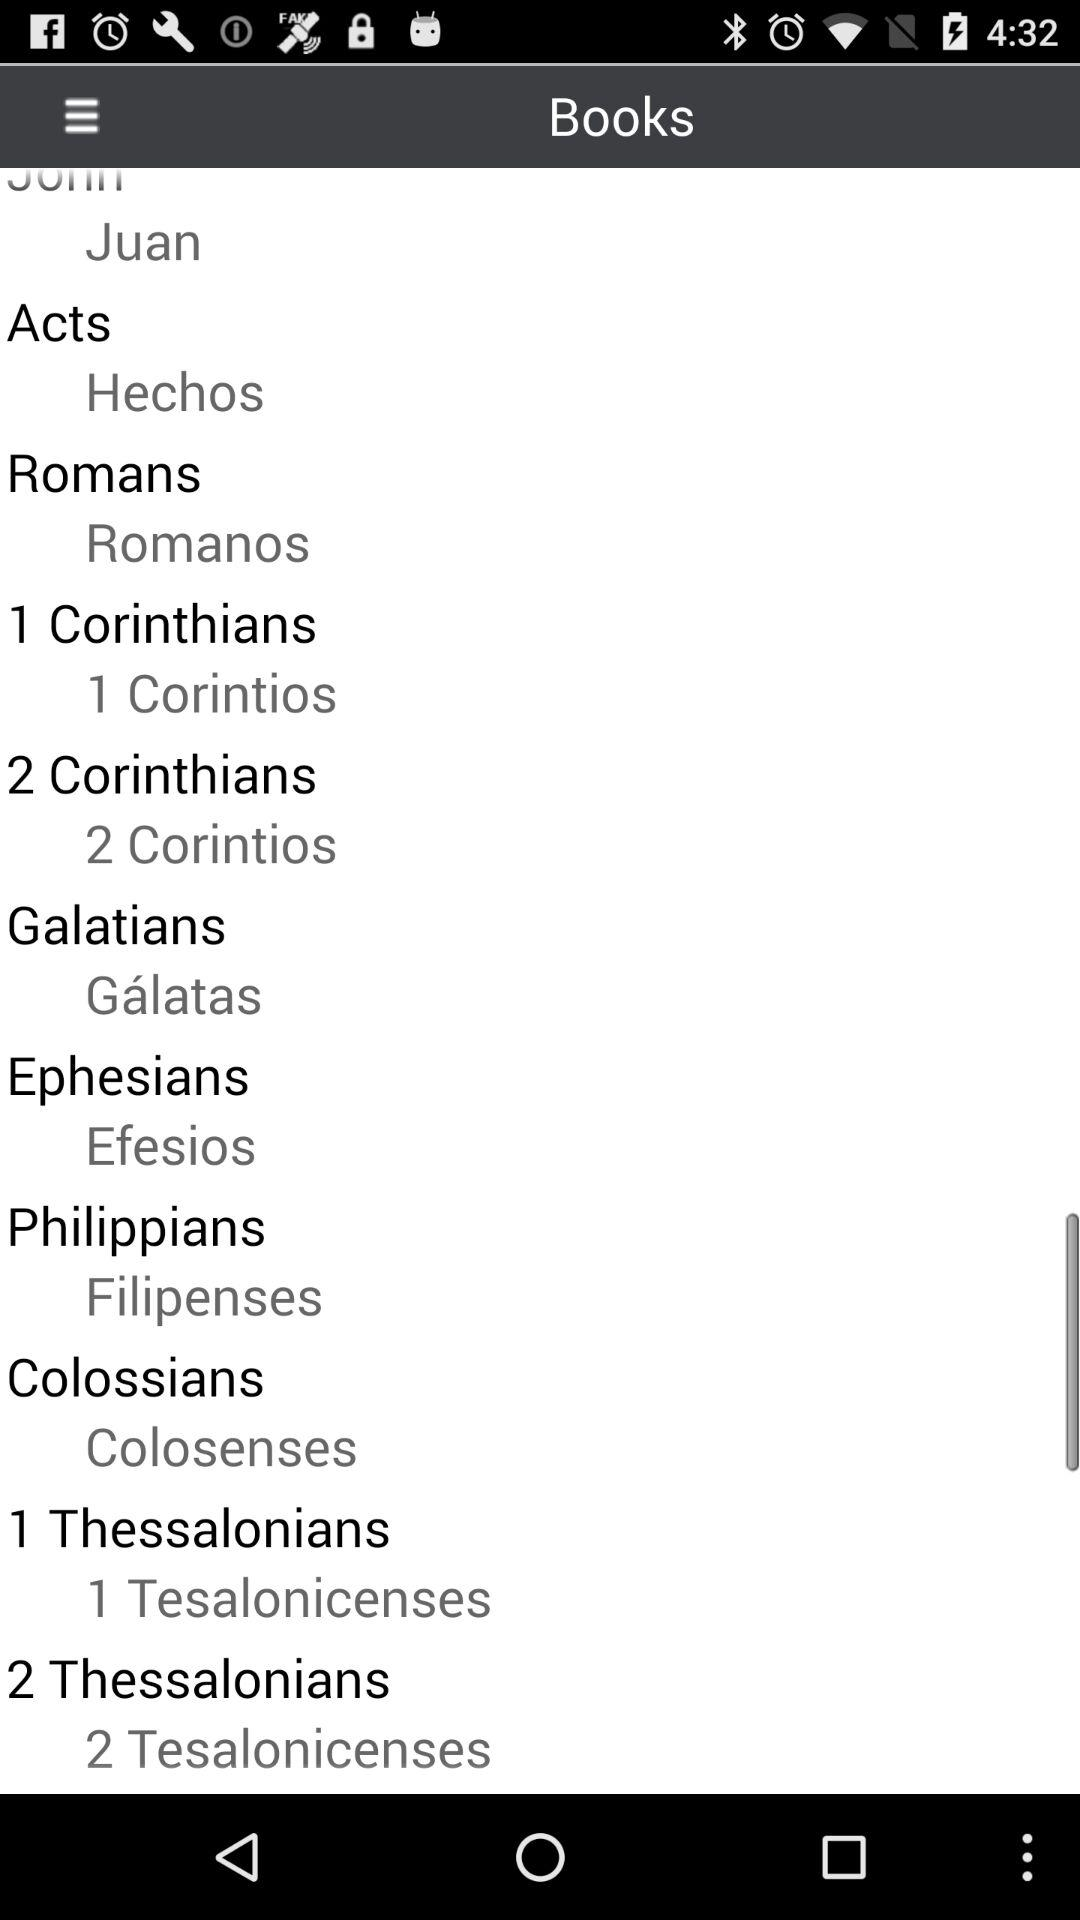What is the romans book name?
When the provided information is insufficient, respond with <no answer>. <no answer> 